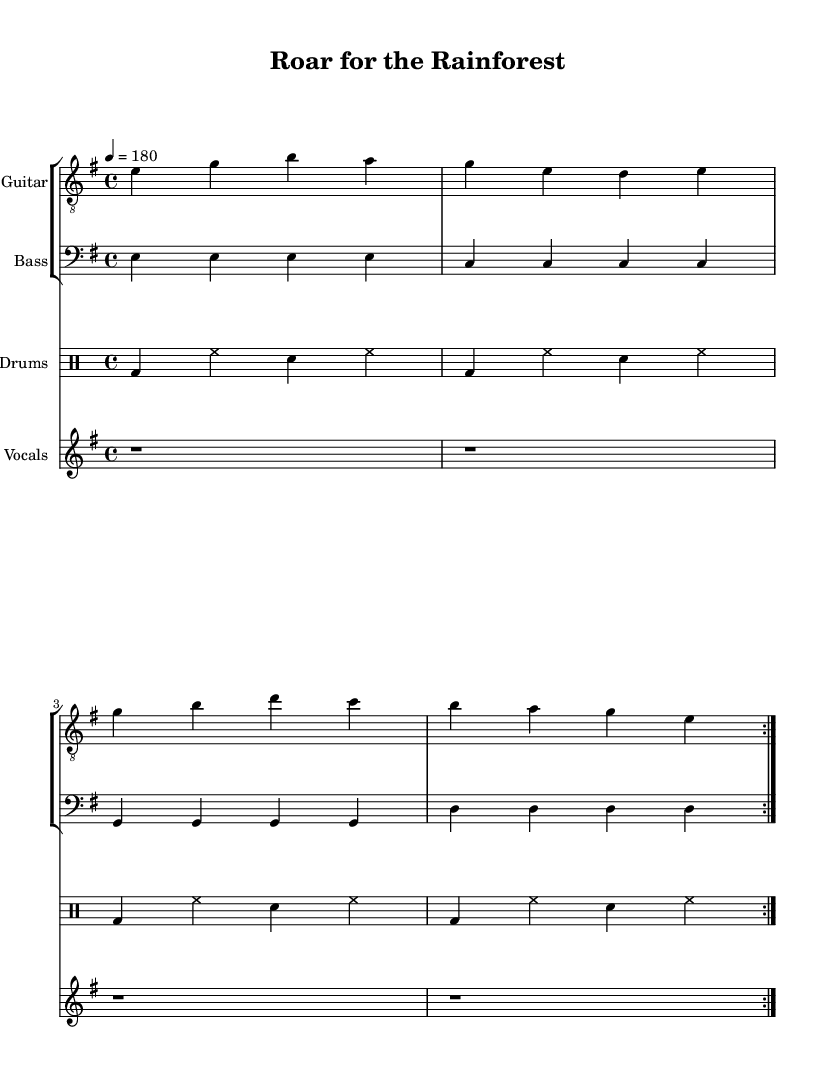what is the key signature of this music? The key signature is indicated in the beginning of the score. It shows that there are no sharps or flats, which corresponds to E minor.
Answer: E minor what is the time signature of this music? The time signature is noted at the beginning of the score next to the key signature. It indicates 4 beats in each measure.
Answer: 4/4 what is the tempo of this music? The tempo is specified in the score as "4 = 180," indicating the beats per minute. The "4" refers to the note value (quarter note), and "180" indicates the speed.
Answer: 180 how many measures are repeated in the guitar section? The repeated section in the guitar part is denoted by the "volta" marking, which indicates that the specific music plays two times.
Answer: 2 what instruments are included in this score? The instruments are explicitly mentioned in the score. They include Guitar, Bass, Drums, and Vocals.
Answer: Guitar, Bass, Drums, Vocals what is the subject celebrated in the lyrics of this piece? The lyrics reflect a theme of wildlife and habitat conservation, mentioning "Jungle" and "Rainforest." The lyrics promote the protection of endangered species and their environment.
Answer: Endangered species what kind of rhythm is predominantly featured in the drum section? The drum section follows a basic rock beat pattern, characterized by bass drums, hi-hats, and snare hits that create a driving, fast-paced rhythm typical of punk music.
Answer: Rock beat 